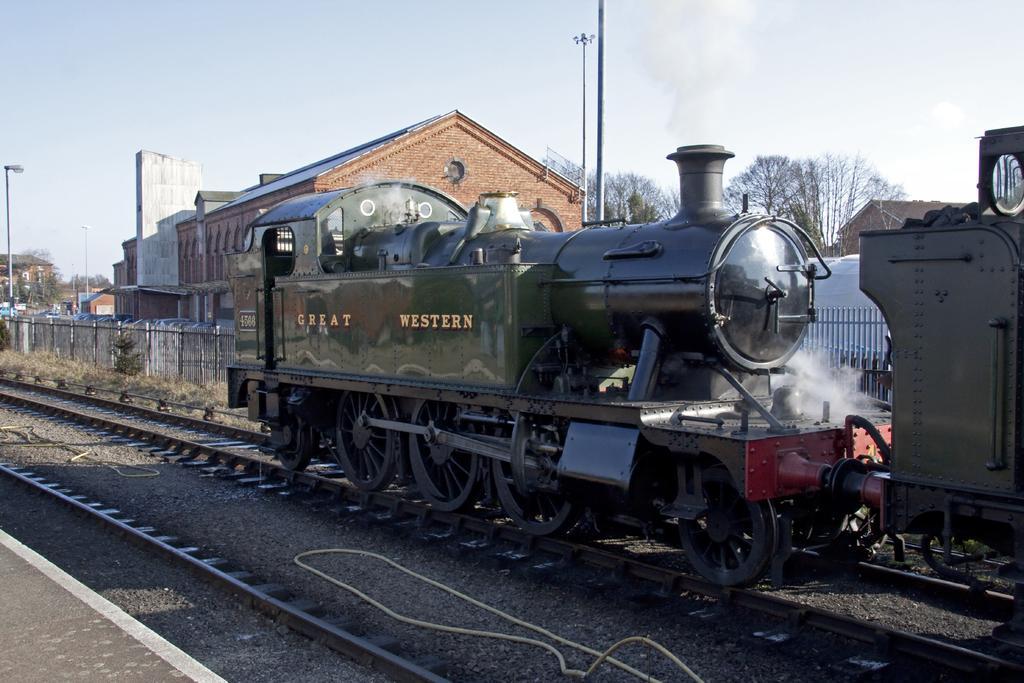Can you describe this image briefly? In this image, we can see the train. We can see some railway tracks. We can also see some houses, trees, plants, poles. We can see the ground with some objects. We can also see the fence and the sky. 